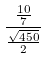Convert formula to latex. <formula><loc_0><loc_0><loc_500><loc_500>\frac { \frac { 1 0 } { 7 } } { \frac { \sqrt { 4 5 0 } } { 2 } }</formula> 